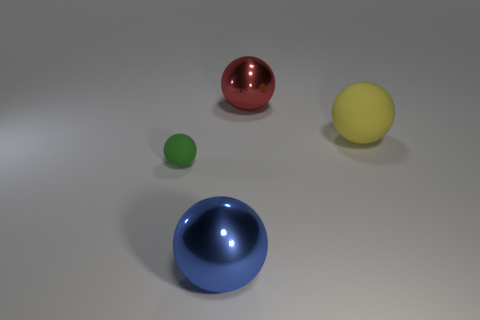Add 2 things. How many objects exist? 6 Subtract all green matte balls. Subtract all large blue matte things. How many objects are left? 3 Add 1 matte balls. How many matte balls are left? 3 Add 2 rubber things. How many rubber things exist? 4 Subtract 0 brown balls. How many objects are left? 4 